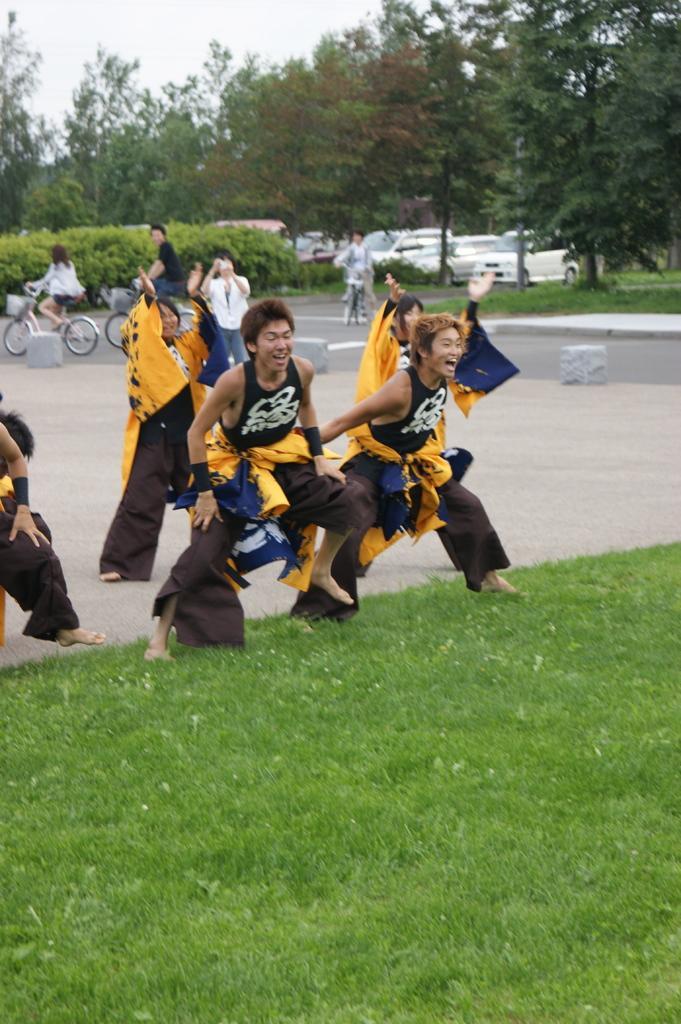Describe this image in one or two sentences. In this image we can see these people wearing different costumes are standing on the road. Here we can see the grass. In the background, we can see these people are riding bicycles, we can see shrubs, cars parked here, trees and the sky. 